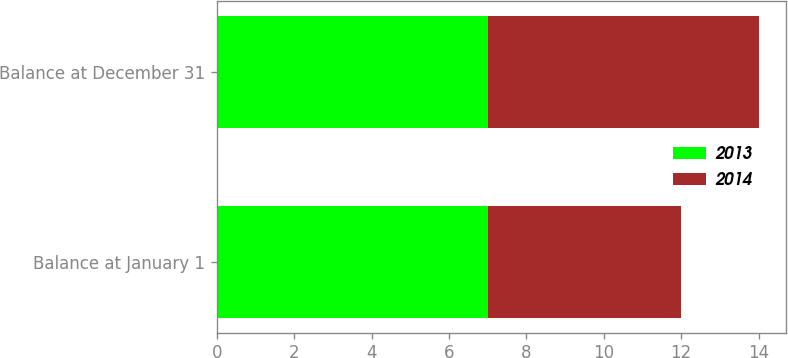Convert chart. <chart><loc_0><loc_0><loc_500><loc_500><stacked_bar_chart><ecel><fcel>Balance at January 1<fcel>Balance at December 31<nl><fcel>2013<fcel>7<fcel>7<nl><fcel>2014<fcel>5<fcel>7<nl></chart> 